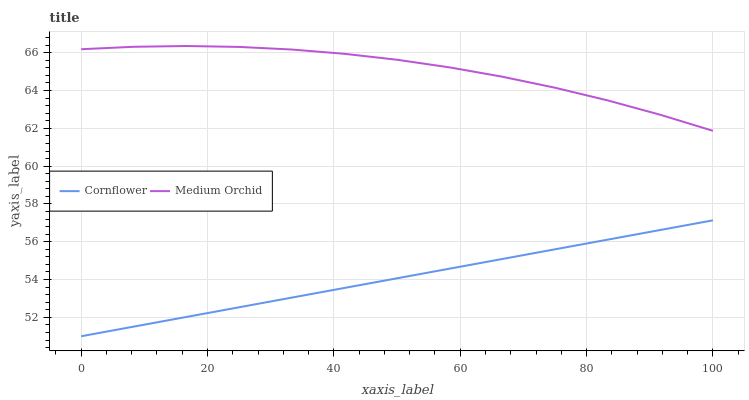Does Medium Orchid have the minimum area under the curve?
Answer yes or no. No. Is Medium Orchid the smoothest?
Answer yes or no. No. Does Medium Orchid have the lowest value?
Answer yes or no. No. Is Cornflower less than Medium Orchid?
Answer yes or no. Yes. Is Medium Orchid greater than Cornflower?
Answer yes or no. Yes. Does Cornflower intersect Medium Orchid?
Answer yes or no. No. 